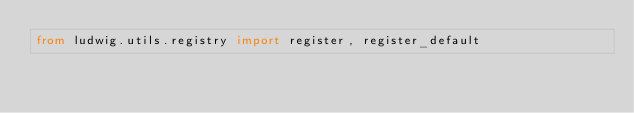Convert code to text. <code><loc_0><loc_0><loc_500><loc_500><_Python_>from ludwig.utils.registry import register, register_default
</code> 